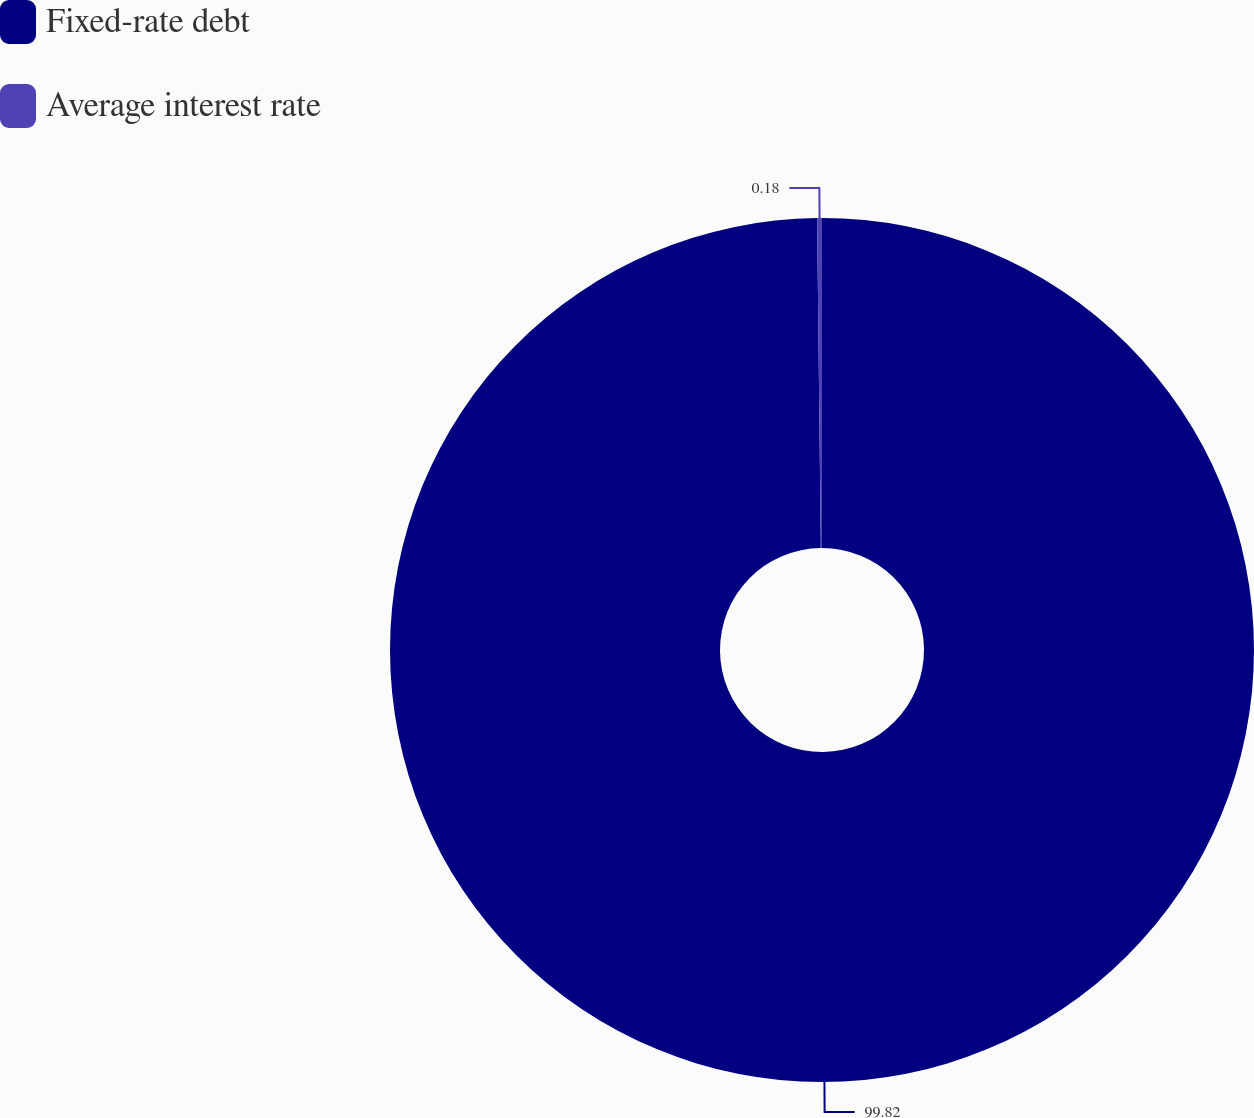<chart> <loc_0><loc_0><loc_500><loc_500><pie_chart><fcel>Fixed-rate debt<fcel>Average interest rate<nl><fcel>99.82%<fcel>0.18%<nl></chart> 